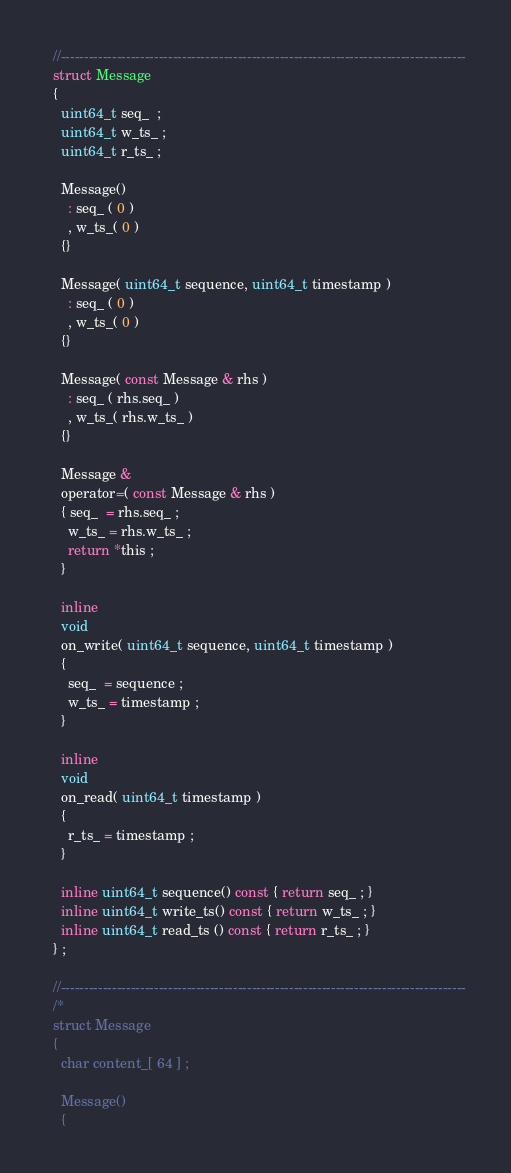Convert code to text. <code><loc_0><loc_0><loc_500><loc_500><_C_>
  //---------------------------------------------------------------------------------------
  struct Message 
  {
    uint64_t seq_  ;
    uint64_t w_ts_ ;
    uint64_t r_ts_ ;

    Message() 
      : seq_ ( 0 ) 
      , w_ts_( 0 )
    {}

    Message( uint64_t sequence, uint64_t timestamp ) 
      : seq_ ( 0 ) 
      , w_ts_( 0 )
    {}

    Message( const Message & rhs ) 
      : seq_ ( rhs.seq_ ) 
      , w_ts_( rhs.w_ts_ ) 
    {}

    Message & 
    operator=( const Message & rhs ) 
    { seq_  = rhs.seq_ ;
      w_ts_ = rhs.w_ts_ ;
      return *this ;
    }

    inline 
    void 
    on_write( uint64_t sequence, uint64_t timestamp ) 
    { 
      seq_  = sequence ;
      w_ts_ = timestamp ;
    }

    inline 
    void 
    on_read( uint64_t timestamp )
    { 
      r_ts_ = timestamp ;
    }

    inline uint64_t sequence() const { return seq_ ; }
    inline uint64_t write_ts() const { return w_ts_ ; }
    inline uint64_t read_ts () const { return r_ts_ ; }
  } ;

  //---------------------------------------------------------------------------------------
  /*
  struct Message
  {
    char content_[ 64 ] ; 

    Message() 
    {</code> 